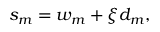Convert formula to latex. <formula><loc_0><loc_0><loc_500><loc_500>\begin{array} { r } { s _ { m } = w _ { m } + \xi d _ { m } , } \end{array}</formula> 